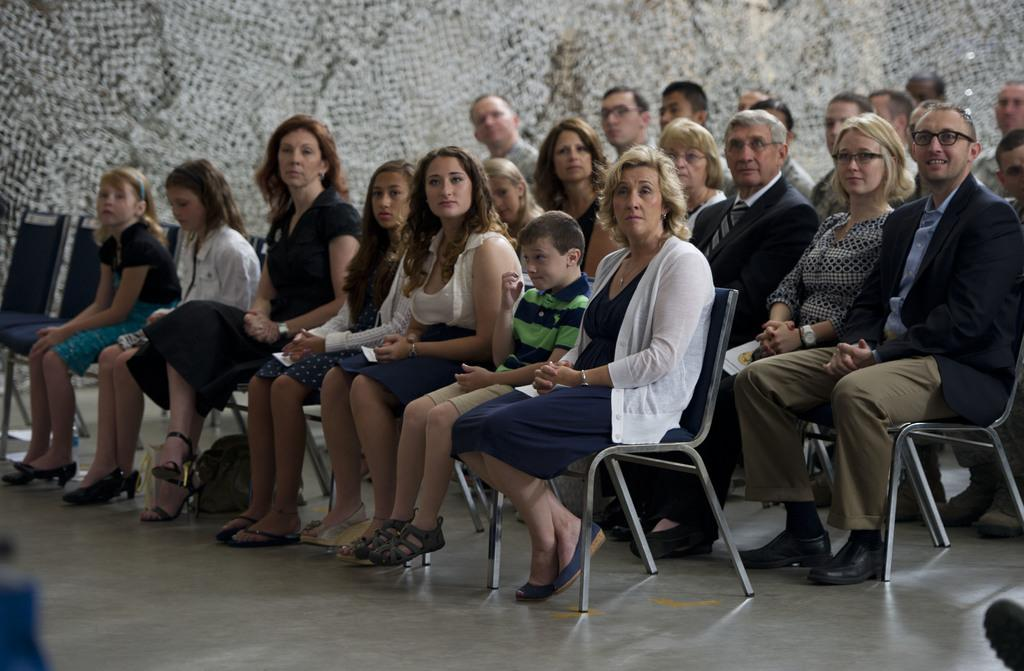Where was the image taken? The image was taken in a hall. What can be seen in the hall? There are many chairs in the hall. Who is present in the hall? There are women, men, and kids in the hall. What are the people doing in the hall? The people are sitting on the chairs. What color is the shop in the image? There is no shop present in the image; it was taken in a hall with chairs and people. 